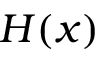<formula> <loc_0><loc_0><loc_500><loc_500>H ( x )</formula> 